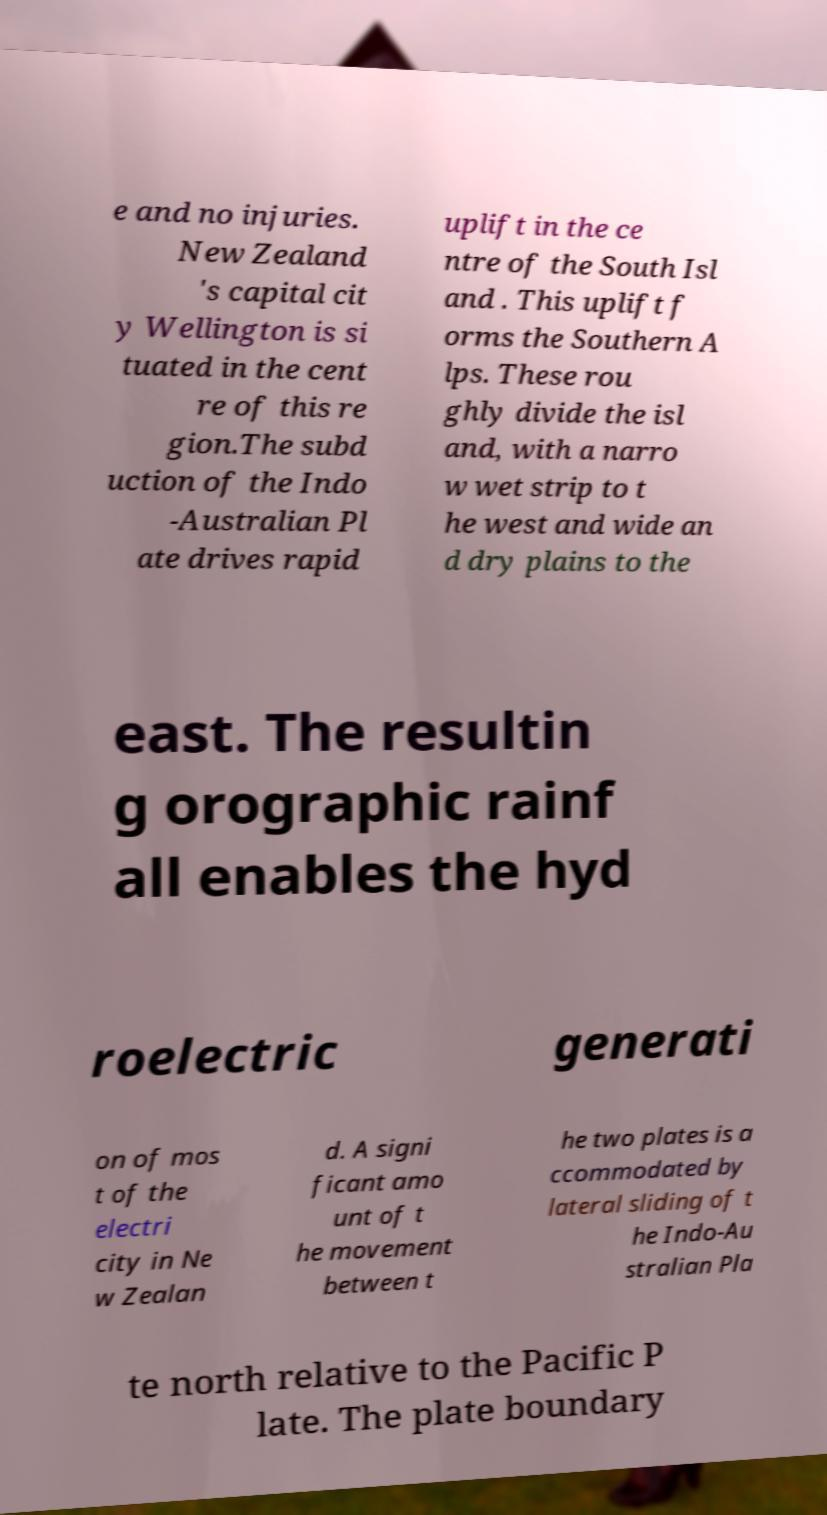For documentation purposes, I need the text within this image transcribed. Could you provide that? e and no injuries. New Zealand 's capital cit y Wellington is si tuated in the cent re of this re gion.The subd uction of the Indo -Australian Pl ate drives rapid uplift in the ce ntre of the South Isl and . This uplift f orms the Southern A lps. These rou ghly divide the isl and, with a narro w wet strip to t he west and wide an d dry plains to the east. The resultin g orographic rainf all enables the hyd roelectric generati on of mos t of the electri city in Ne w Zealan d. A signi ficant amo unt of t he movement between t he two plates is a ccommodated by lateral sliding of t he Indo-Au stralian Pla te north relative to the Pacific P late. The plate boundary 